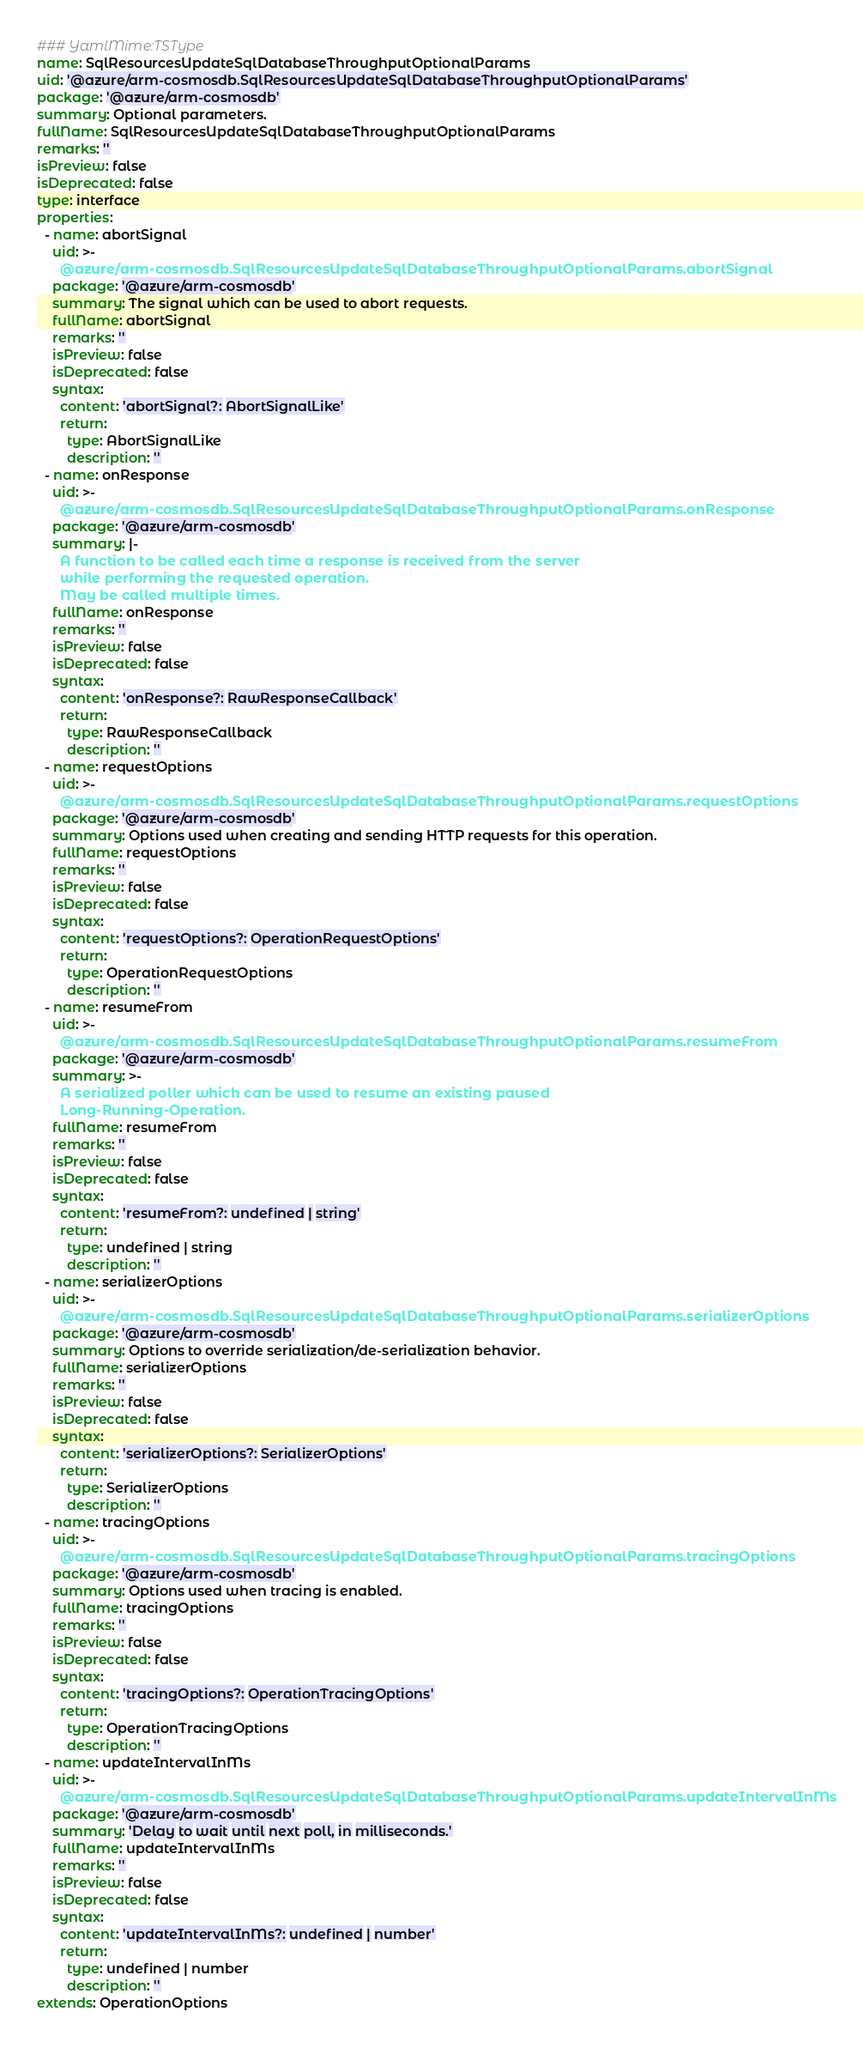Convert code to text. <code><loc_0><loc_0><loc_500><loc_500><_YAML_>### YamlMime:TSType
name: SqlResourcesUpdateSqlDatabaseThroughputOptionalParams
uid: '@azure/arm-cosmosdb.SqlResourcesUpdateSqlDatabaseThroughputOptionalParams'
package: '@azure/arm-cosmosdb'
summary: Optional parameters.
fullName: SqlResourcesUpdateSqlDatabaseThroughputOptionalParams
remarks: ''
isPreview: false
isDeprecated: false
type: interface
properties:
  - name: abortSignal
    uid: >-
      @azure/arm-cosmosdb.SqlResourcesUpdateSqlDatabaseThroughputOptionalParams.abortSignal
    package: '@azure/arm-cosmosdb'
    summary: The signal which can be used to abort requests.
    fullName: abortSignal
    remarks: ''
    isPreview: false
    isDeprecated: false
    syntax:
      content: 'abortSignal?: AbortSignalLike'
      return:
        type: AbortSignalLike
        description: ''
  - name: onResponse
    uid: >-
      @azure/arm-cosmosdb.SqlResourcesUpdateSqlDatabaseThroughputOptionalParams.onResponse
    package: '@azure/arm-cosmosdb'
    summary: |-
      A function to be called each time a response is received from the server
      while performing the requested operation.
      May be called multiple times.
    fullName: onResponse
    remarks: ''
    isPreview: false
    isDeprecated: false
    syntax:
      content: 'onResponse?: RawResponseCallback'
      return:
        type: RawResponseCallback
        description: ''
  - name: requestOptions
    uid: >-
      @azure/arm-cosmosdb.SqlResourcesUpdateSqlDatabaseThroughputOptionalParams.requestOptions
    package: '@azure/arm-cosmosdb'
    summary: Options used when creating and sending HTTP requests for this operation.
    fullName: requestOptions
    remarks: ''
    isPreview: false
    isDeprecated: false
    syntax:
      content: 'requestOptions?: OperationRequestOptions'
      return:
        type: OperationRequestOptions
        description: ''
  - name: resumeFrom
    uid: >-
      @azure/arm-cosmosdb.SqlResourcesUpdateSqlDatabaseThroughputOptionalParams.resumeFrom
    package: '@azure/arm-cosmosdb'
    summary: >-
      A serialized poller which can be used to resume an existing paused
      Long-Running-Operation.
    fullName: resumeFrom
    remarks: ''
    isPreview: false
    isDeprecated: false
    syntax:
      content: 'resumeFrom?: undefined | string'
      return:
        type: undefined | string
        description: ''
  - name: serializerOptions
    uid: >-
      @azure/arm-cosmosdb.SqlResourcesUpdateSqlDatabaseThroughputOptionalParams.serializerOptions
    package: '@azure/arm-cosmosdb'
    summary: Options to override serialization/de-serialization behavior.
    fullName: serializerOptions
    remarks: ''
    isPreview: false
    isDeprecated: false
    syntax:
      content: 'serializerOptions?: SerializerOptions'
      return:
        type: SerializerOptions
        description: ''
  - name: tracingOptions
    uid: >-
      @azure/arm-cosmosdb.SqlResourcesUpdateSqlDatabaseThroughputOptionalParams.tracingOptions
    package: '@azure/arm-cosmosdb'
    summary: Options used when tracing is enabled.
    fullName: tracingOptions
    remarks: ''
    isPreview: false
    isDeprecated: false
    syntax:
      content: 'tracingOptions?: OperationTracingOptions'
      return:
        type: OperationTracingOptions
        description: ''
  - name: updateIntervalInMs
    uid: >-
      @azure/arm-cosmosdb.SqlResourcesUpdateSqlDatabaseThroughputOptionalParams.updateIntervalInMs
    package: '@azure/arm-cosmosdb'
    summary: 'Delay to wait until next poll, in milliseconds.'
    fullName: updateIntervalInMs
    remarks: ''
    isPreview: false
    isDeprecated: false
    syntax:
      content: 'updateIntervalInMs?: undefined | number'
      return:
        type: undefined | number
        description: ''
extends: OperationOptions
</code> 